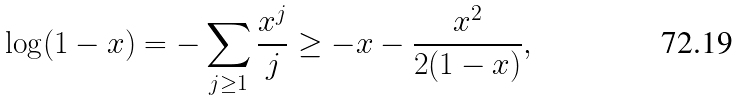<formula> <loc_0><loc_0><loc_500><loc_500>\log ( 1 - x ) = - \sum _ { j \geq 1 } \frac { x ^ { j } } { j } \geq - x - \frac { x ^ { 2 } } { 2 ( 1 - x ) } ,</formula> 